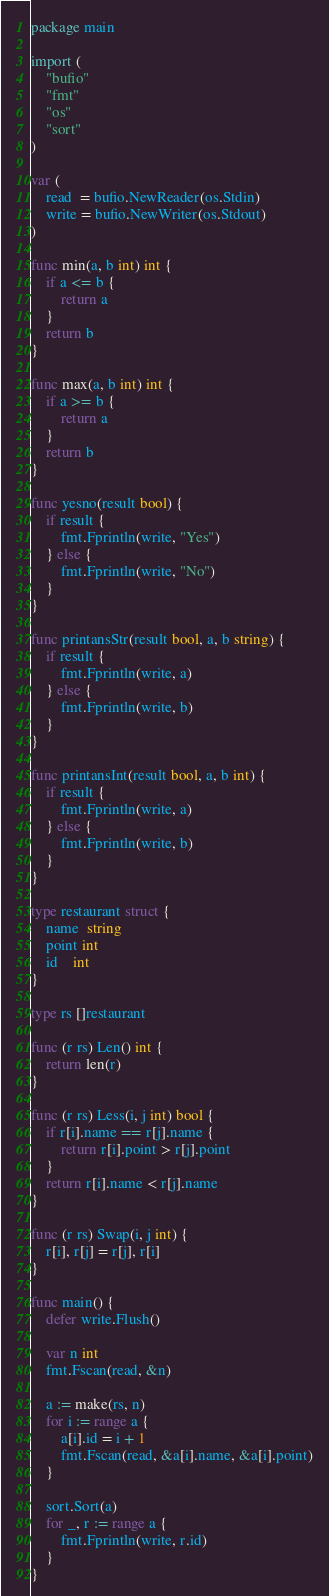<code> <loc_0><loc_0><loc_500><loc_500><_Go_>package main

import (
	"bufio"
	"fmt"
	"os"
	"sort"
)

var (
	read  = bufio.NewReader(os.Stdin)
	write = bufio.NewWriter(os.Stdout)
)

func min(a, b int) int {
	if a <= b {
		return a
	}
	return b
}

func max(a, b int) int {
	if a >= b {
		return a
	}
	return b
}

func yesno(result bool) {
	if result {
		fmt.Fprintln(write, "Yes")
	} else {
		fmt.Fprintln(write, "No")
	}
}

func printansStr(result bool, a, b string) {
	if result {
		fmt.Fprintln(write, a)
	} else {
		fmt.Fprintln(write, b)
	}
}

func printansInt(result bool, a, b int) {
	if result {
		fmt.Fprintln(write, a)
	} else {
		fmt.Fprintln(write, b)
	}
}

type restaurant struct {
	name  string
	point int
	id    int
}

type rs []restaurant

func (r rs) Len() int {
	return len(r)
}

func (r rs) Less(i, j int) bool {
	if r[i].name == r[j].name {
		return r[i].point > r[j].point
	}
	return r[i].name < r[j].name
}

func (r rs) Swap(i, j int) {
	r[i], r[j] = r[j], r[i]
}

func main() {
	defer write.Flush()

	var n int
	fmt.Fscan(read, &n)

	a := make(rs, n)
	for i := range a {
		a[i].id = i + 1
		fmt.Fscan(read, &a[i].name, &a[i].point)
	}

	sort.Sort(a)
	for _, r := range a {
		fmt.Fprintln(write, r.id)
	}
}
</code> 